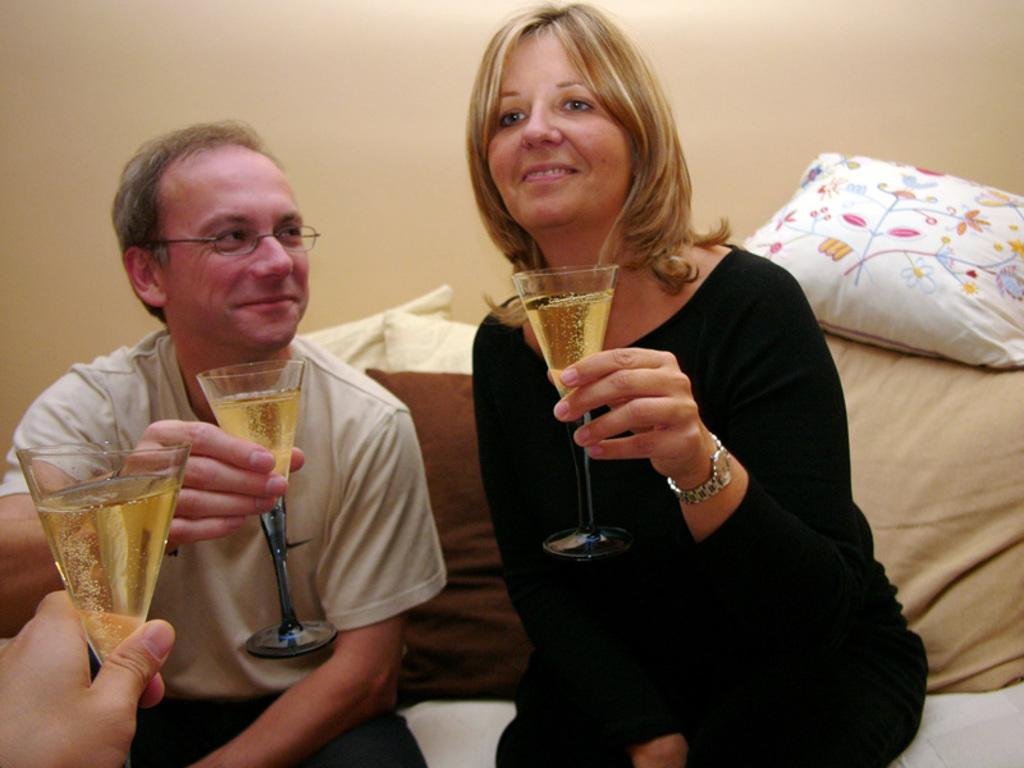How many people are in the image? There are two people in the image, a man and a woman. What are the man and woman holding in their hands? Both the man and woman are holding a glass with their hands. What is the facial expression of the man in the image? The man is smiling. What accessory is the man wearing in the image? The man is wearing spectacles. What type of furniture can be seen in the image? There are pillows in the image. What is the background of the image? There is a wall in the image. What type of sugar is being used to sweeten the lead in the image? There is no sugar or lead present in the image; it features a man and a woman holding glasses. 